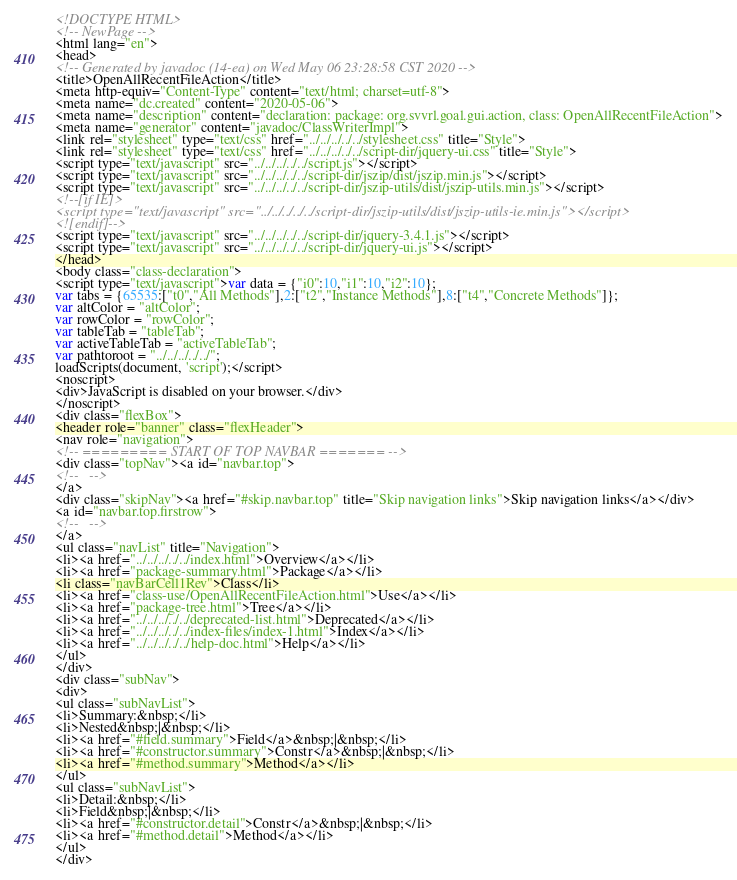Convert code to text. <code><loc_0><loc_0><loc_500><loc_500><_HTML_><!DOCTYPE HTML>
<!-- NewPage -->
<html lang="en">
<head>
<!-- Generated by javadoc (14-ea) on Wed May 06 23:28:58 CST 2020 -->
<title>OpenAllRecentFileAction</title>
<meta http-equiv="Content-Type" content="text/html; charset=utf-8">
<meta name="dc.created" content="2020-05-06">
<meta name="description" content="declaration: package: org.svvrl.goal.gui.action, class: OpenAllRecentFileAction">
<meta name="generator" content="javadoc/ClassWriterImpl">
<link rel="stylesheet" type="text/css" href="../../../../../stylesheet.css" title="Style">
<link rel="stylesheet" type="text/css" href="../../../../../script-dir/jquery-ui.css" title="Style">
<script type="text/javascript" src="../../../../../script.js"></script>
<script type="text/javascript" src="../../../../../script-dir/jszip/dist/jszip.min.js"></script>
<script type="text/javascript" src="../../../../../script-dir/jszip-utils/dist/jszip-utils.min.js"></script>
<!--[if IE]>
<script type="text/javascript" src="../../../../../script-dir/jszip-utils/dist/jszip-utils-ie.min.js"></script>
<![endif]-->
<script type="text/javascript" src="../../../../../script-dir/jquery-3.4.1.js"></script>
<script type="text/javascript" src="../../../../../script-dir/jquery-ui.js"></script>
</head>
<body class="class-declaration">
<script type="text/javascript">var data = {"i0":10,"i1":10,"i2":10};
var tabs = {65535:["t0","All Methods"],2:["t2","Instance Methods"],8:["t4","Concrete Methods"]};
var altColor = "altColor";
var rowColor = "rowColor";
var tableTab = "tableTab";
var activeTableTab = "activeTableTab";
var pathtoroot = "../../../../../";
loadScripts(document, 'script');</script>
<noscript>
<div>JavaScript is disabled on your browser.</div>
</noscript>
<div class="flexBox">
<header role="banner" class="flexHeader">
<nav role="navigation">
<!-- ========= START OF TOP NAVBAR ======= -->
<div class="topNav"><a id="navbar.top">
<!--   -->
</a>
<div class="skipNav"><a href="#skip.navbar.top" title="Skip navigation links">Skip navigation links</a></div>
<a id="navbar.top.firstrow">
<!--   -->
</a>
<ul class="navList" title="Navigation">
<li><a href="../../../../../index.html">Overview</a></li>
<li><a href="package-summary.html">Package</a></li>
<li class="navBarCell1Rev">Class</li>
<li><a href="class-use/OpenAllRecentFileAction.html">Use</a></li>
<li><a href="package-tree.html">Tree</a></li>
<li><a href="../../../../../deprecated-list.html">Deprecated</a></li>
<li><a href="../../../../../index-files/index-1.html">Index</a></li>
<li><a href="../../../../../help-doc.html">Help</a></li>
</ul>
</div>
<div class="subNav">
<div>
<ul class="subNavList">
<li>Summary:&nbsp;</li>
<li>Nested&nbsp;|&nbsp;</li>
<li><a href="#field.summary">Field</a>&nbsp;|&nbsp;</li>
<li><a href="#constructor.summary">Constr</a>&nbsp;|&nbsp;</li>
<li><a href="#method.summary">Method</a></li>
</ul>
<ul class="subNavList">
<li>Detail:&nbsp;</li>
<li>Field&nbsp;|&nbsp;</li>
<li><a href="#constructor.detail">Constr</a>&nbsp;|&nbsp;</li>
<li><a href="#method.detail">Method</a></li>
</ul>
</div></code> 